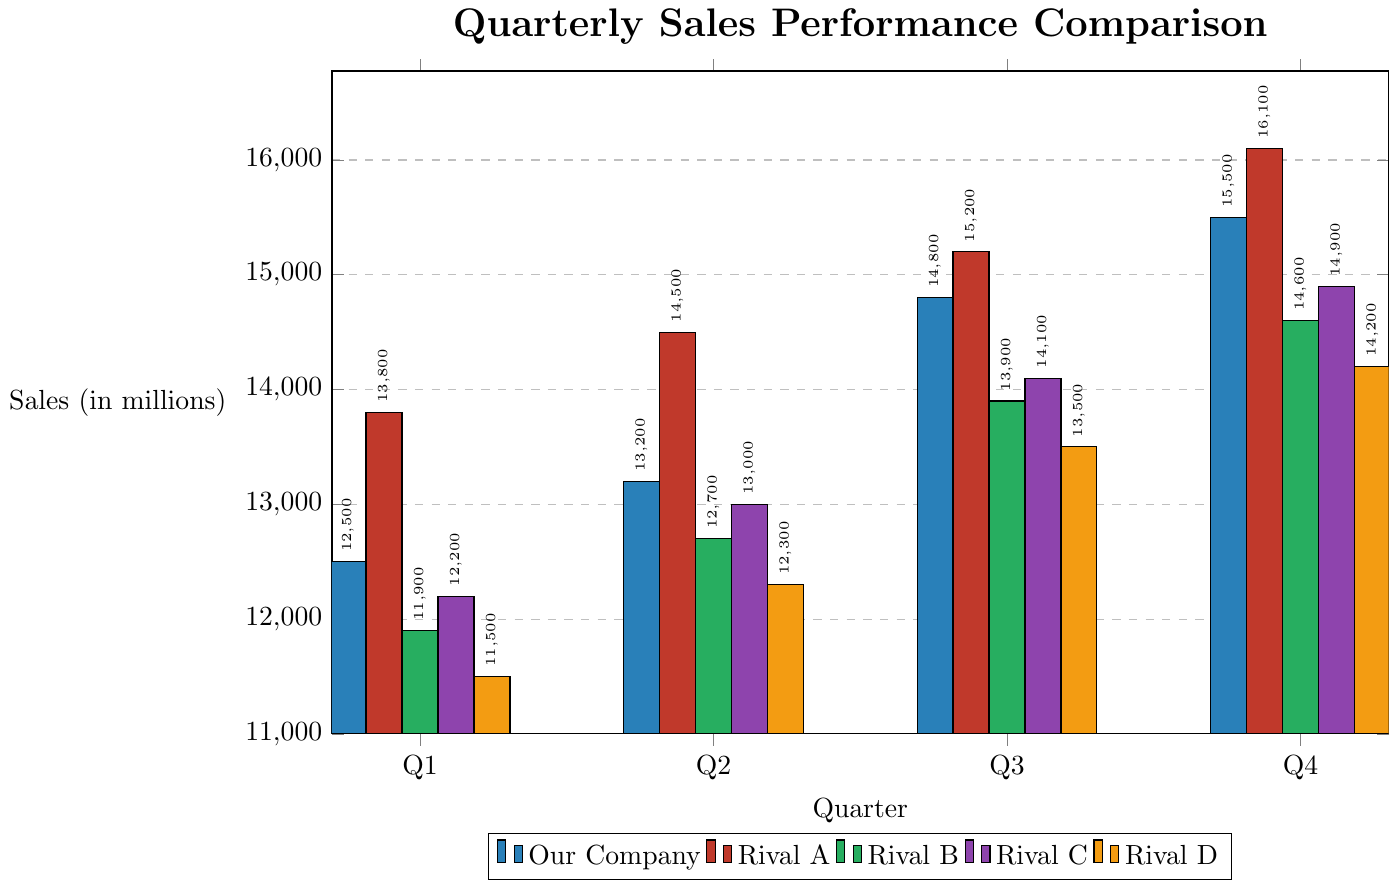What's the highest sales figure for Our Company? Look at the bar representing Our Company in each quarter and find the tallest bar. The highest sales figure will be its value. For Q4, the value is 15.5 million.
Answer: 15.5 million Which company had the highest sales in Q3? Compare the heights of the bars for Q3 to find the tallest one. For Q3, Rival A's bar is the tallest with a value of 15.2 million.
Answer: Rival A How does Q1 performance for Our Company compare to Q1 for Rival B? Look at the heights of the bars for Our Company and Rival B in Q1. Our Company's value is 12.5 million and Rival B's value is 11.9 million. So, Our Company did better by 0.6 million.
Answer: Our Company is 0.6 million higher What is the total sales for Rival C across all quarters? Add the values of Rival C's bars for all quarters: \(12.2 + 13.0 + 14.1 + 14.9 = 54.2\) million.
Answer: 54.2 million Which company showed the largest increase in sales from Q1 to Q4? Calculate the difference between Q4 and Q1 for each company, then compare these values: Our Company (3.0 million), Rival A (2.3 million), Rival B (2.7 million), Rival C (2.7 million), Rival D (2.7 million). Our Company has the largest increase.
Answer: Our Company What is the average sales of Rival A in Q2 and Q3? Add the values for Q2 and Q3, then divide by 2: \((14.5 + 15.2) / 2 = 14.85\) million.
Answer: 14.85 million Compare the Q4 sales of Our Company and Rival D Look at the heights of the bars for both companies in Q4. Our Company's value is 15.5 million and Rival D's value is 14.2 million. Our Company had higher sales by 1.3 million.
Answer: Our Company is 1.3 million higher How much higher are Rival C's Q3 sales compared to Our Company's Q1 sales? Subtract the Q1 sales of Our Company from the Q3 sales of Rival C: \(14.1 - 12.5 = 1.6\) million.
Answer: 1.6 million 